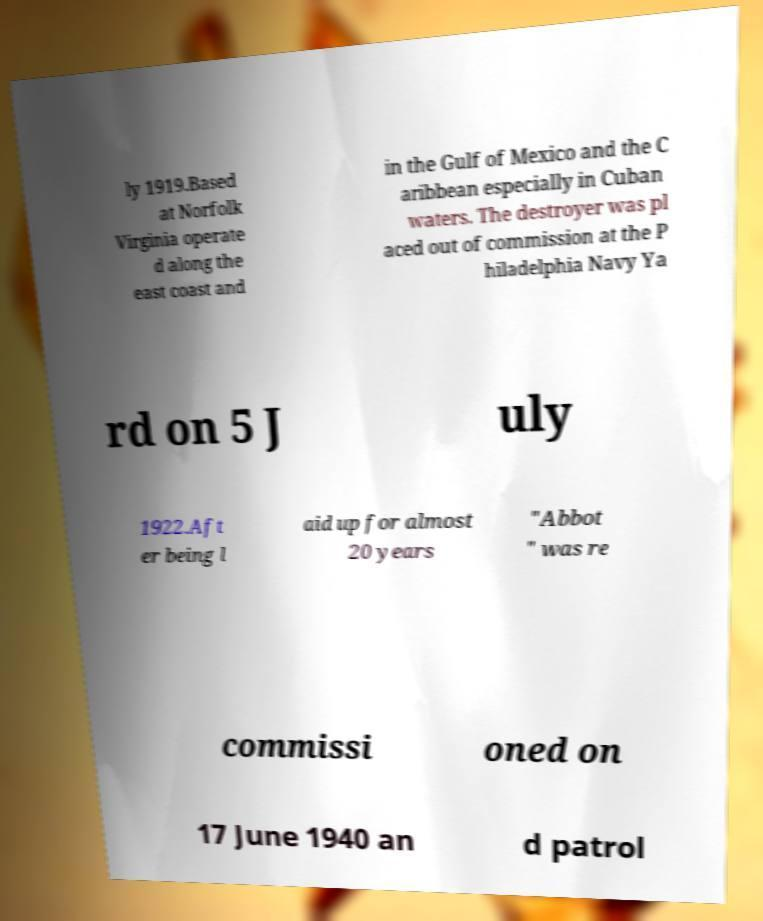Please identify and transcribe the text found in this image. ly 1919.Based at Norfolk Virginia operate d along the east coast and in the Gulf of Mexico and the C aribbean especially in Cuban waters. The destroyer was pl aced out of commission at the P hiladelphia Navy Ya rd on 5 J uly 1922.Aft er being l aid up for almost 20 years "Abbot " was re commissi oned on 17 June 1940 an d patrol 